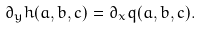Convert formula to latex. <formula><loc_0><loc_0><loc_500><loc_500>\partial _ { y } h ( a , b , c ) = \partial _ { x } q ( a , b , c ) .</formula> 